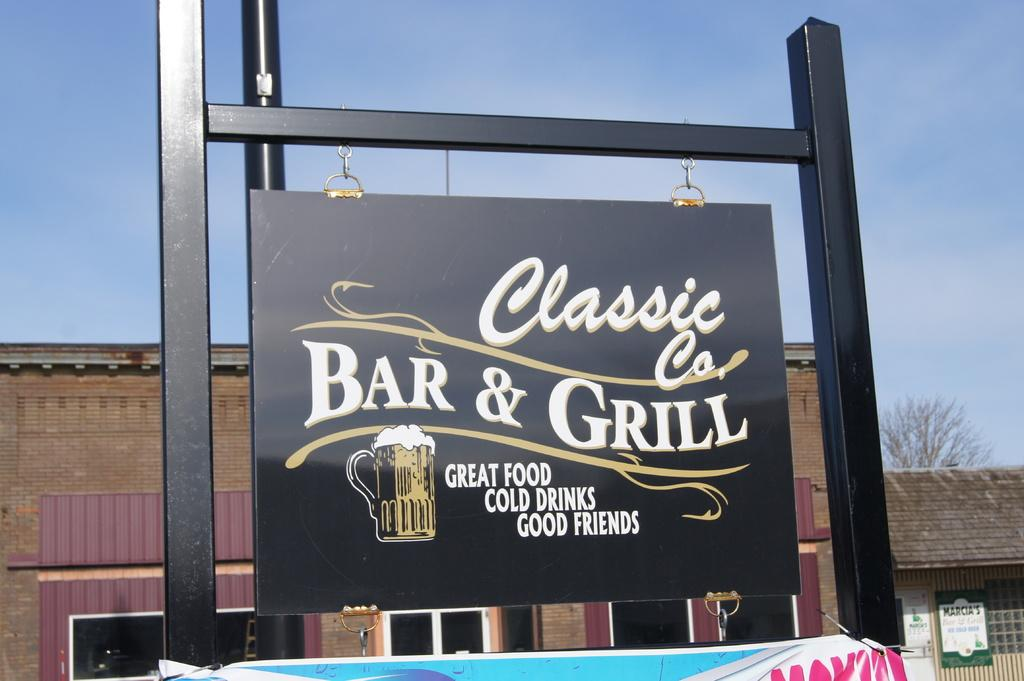<image>
Give a short and clear explanation of the subsequent image. A signpost that says Classic Co's Bar & Grill, displayed in front of a building. 